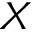<formula> <loc_0><loc_0><loc_500><loc_500>X</formula> 